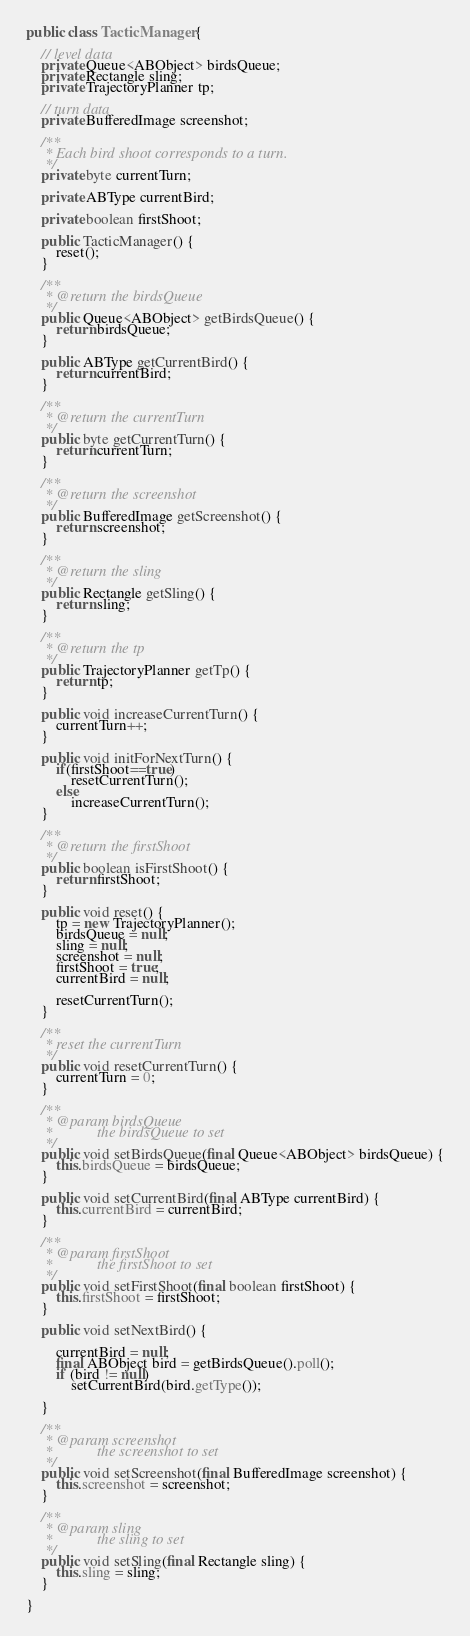Convert code to text. <code><loc_0><loc_0><loc_500><loc_500><_Java_>public class TacticManager {

	// level data
	private Queue<ABObject> birdsQueue;
	private Rectangle sling;
	private TrajectoryPlanner tp;

	// turn data
	private BufferedImage screenshot;

	/**
	 * Each bird shoot corresponds to a turn.
	 */
	private byte currentTurn;

	private ABType currentBird;

	private boolean firstShoot;

	public TacticManager() {
		reset();
	}

	/**
	 * @return the birdsQueue
	 */
	public Queue<ABObject> getBirdsQueue() {
		return birdsQueue;
	}

	public ABType getCurrentBird() {
		return currentBird;
	}

	/**
	 * @return the currentTurn
	 */
	public byte getCurrentTurn() {
		return currentTurn;
	}

	/**
	 * @return the screenshot
	 */
	public BufferedImage getScreenshot() {
		return screenshot;
	}

	/**
	 * @return the sling
	 */
	public Rectangle getSling() {
		return sling;
	}

	/**
	 * @return the tp
	 */
	public TrajectoryPlanner getTp() {
		return tp;
	}

	public void increaseCurrentTurn() {
		currentTurn++;
	}

	public void initForNextTurn() {
		if(firstShoot==true)
			resetCurrentTurn();
		else	
			increaseCurrentTurn();
	}

	/**
	 * @return the firstShoot
	 */
	public boolean isFirstShoot() {
		return firstShoot;
	}

	public void reset() {
		tp = new TrajectoryPlanner();
		birdsQueue = null;
		sling = null;
		screenshot = null;
		firstShoot = true;
		currentBird = null;

		resetCurrentTurn();
	}

	/**
	 * reset the currentTurn
	 */
	public void resetCurrentTurn() {
		currentTurn = 0;
	}

	/**
	 * @param birdsQueue
	 *            the birdsQueue to set
	 */
	public void setBirdsQueue(final Queue<ABObject> birdsQueue) {
		this.birdsQueue = birdsQueue;
	}

	public void setCurrentBird(final ABType currentBird) {
		this.currentBird = currentBird;
	}

	/**
	 * @param firstShoot
	 *            the firstShoot to set
	 */
	public void setFirstShoot(final boolean firstShoot) {
		this.firstShoot = firstShoot;
	}

	public void setNextBird() {

		currentBird = null;
		final ABObject bird = getBirdsQueue().poll();
		if (bird != null)
			setCurrentBird(bird.getType());

	}

	/**
	 * @param screenshot
	 *            the screenshot to set
	 */
	public void setScreenshot(final BufferedImage screenshot) {
		this.screenshot = screenshot;
	}

	/**
	 * @param sling
	 *            the sling to set
	 */
	public void setSling(final Rectangle sling) {
		this.sling = sling;
	}

}
</code> 